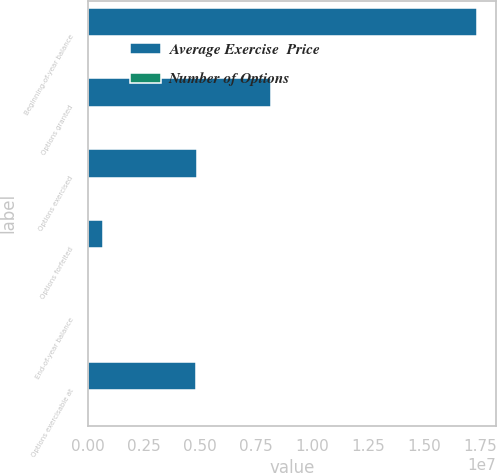Convert chart to OTSL. <chart><loc_0><loc_0><loc_500><loc_500><stacked_bar_chart><ecel><fcel>Beginning-of-year balance<fcel>Options granted<fcel>Options exercised<fcel>Options forfeited<fcel>End-of-year balance<fcel>Options exercisable at<nl><fcel>Average Exercise  Price<fcel>1.73168e+07<fcel>8.16802e+06<fcel>4.87769e+06<fcel>664039<fcel>41.72<fcel>4.83751e+06<nl><fcel>Number of Options<fcel>31.06<fcel>41.72<fcel>28.62<fcel>36.36<fcel>35.85<fcel>31.39<nl></chart> 